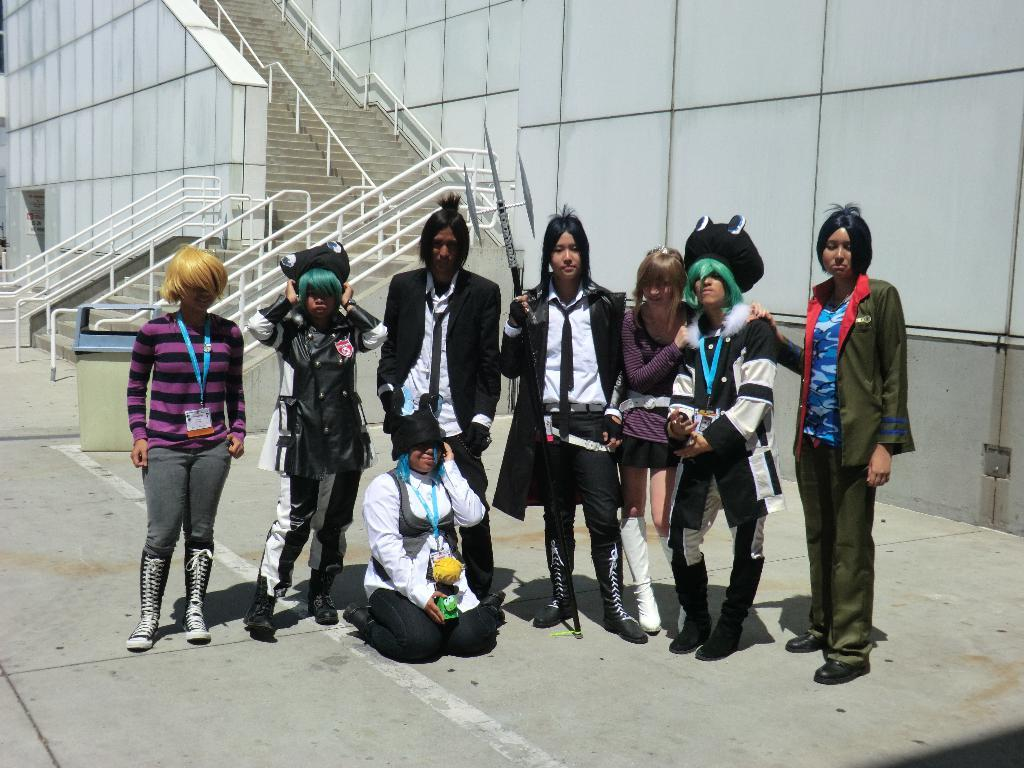What can be observed about the people in the image? There are people standing in the image. What is the surface that the people are standing on? The people are standing on a surface, which could be a floor or platform. What safety feature is visible in the image? There are railings visible in the image, which may provide support or protection. What architectural feature is present in the image? There are stairs in the image, which could be used for ascending or descending. What type of dinner is being served in the image? There is no dinner present in the image; it only shows people standing on a surface with railings and stairs. 